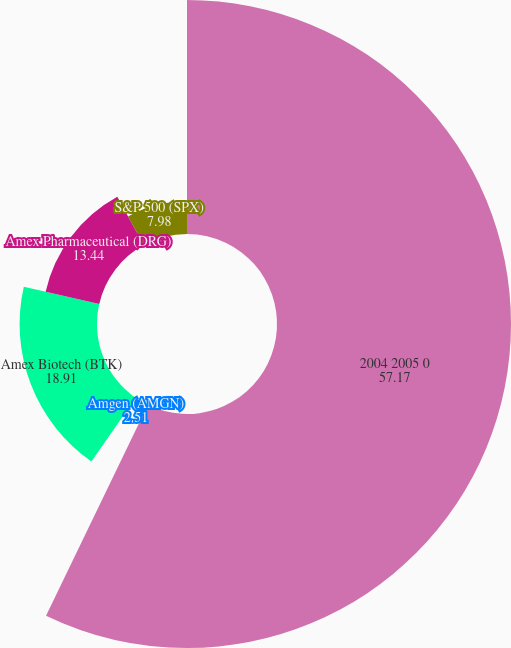Convert chart. <chart><loc_0><loc_0><loc_500><loc_500><pie_chart><fcel>2004 2005 0<fcel>Amgen (AMGN)<fcel>Amex Biotech (BTK)<fcel>Amex Pharmaceutical (DRG)<fcel>S&P 500 (SPX)<nl><fcel>57.17%<fcel>2.51%<fcel>18.91%<fcel>13.44%<fcel>7.98%<nl></chart> 